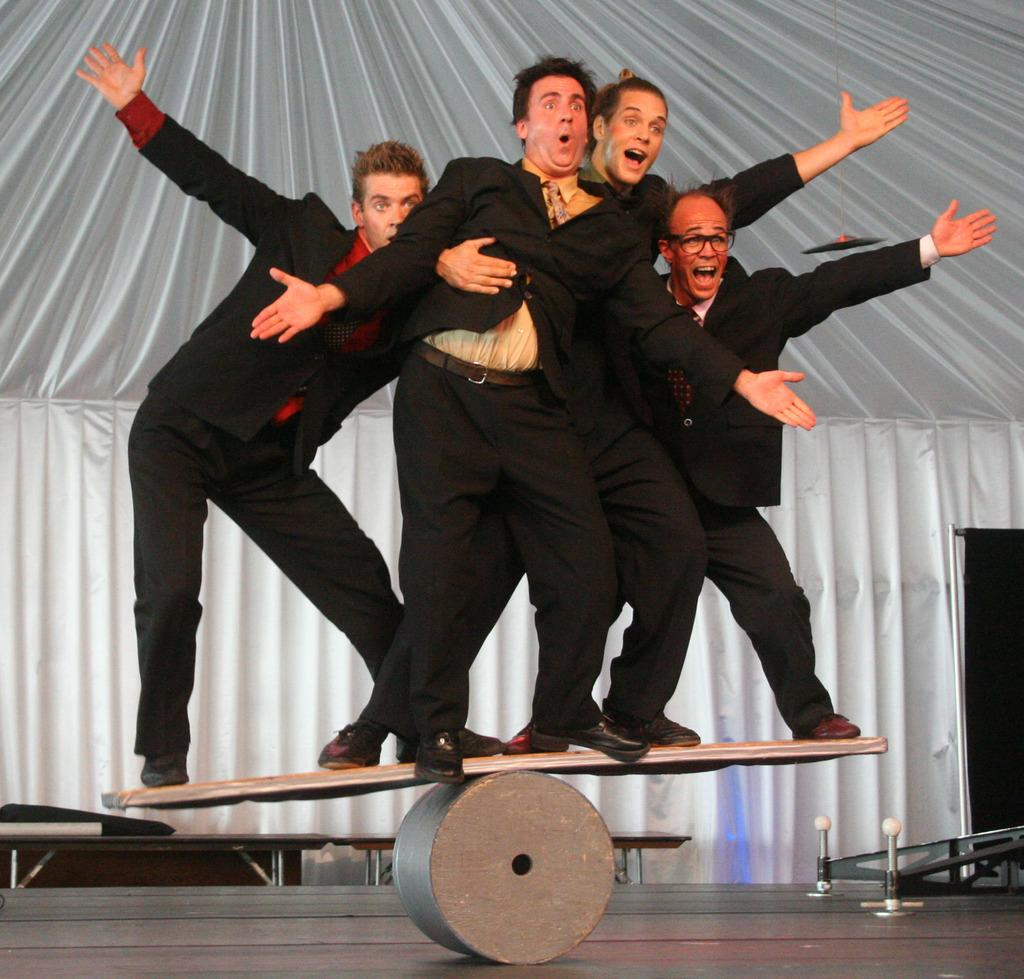What are the people in the image doing? There are persons standing in the center of the image. Can you describe the expressions on their faces? The persons have expressions on their faces. What can be seen in the background of the image? There is a curtain in the background of the image. What color is the curtain? The curtain is white in color. What type of cart is visible in the image? There is no cart present in the image. What historical event is being depicted in the image? The image does not depict any specific historical event. 